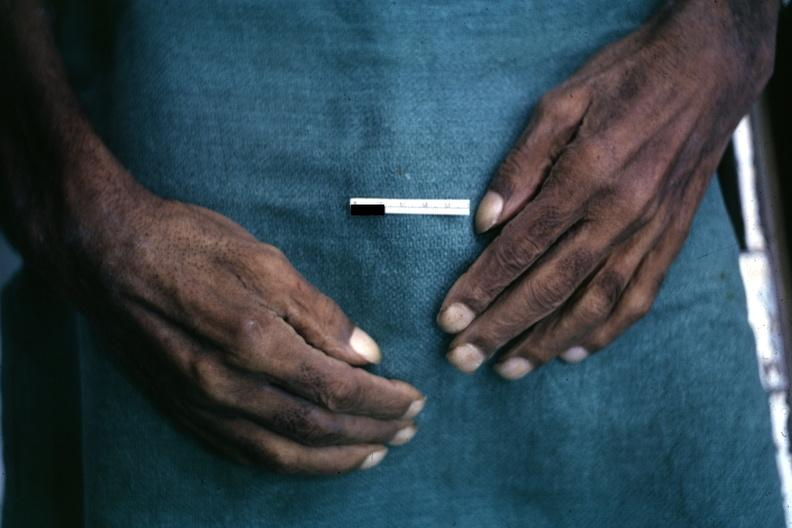re external view of gland with knife cuts into parenchyma hemorrhage present?
Answer the question using a single word or phrase. No 